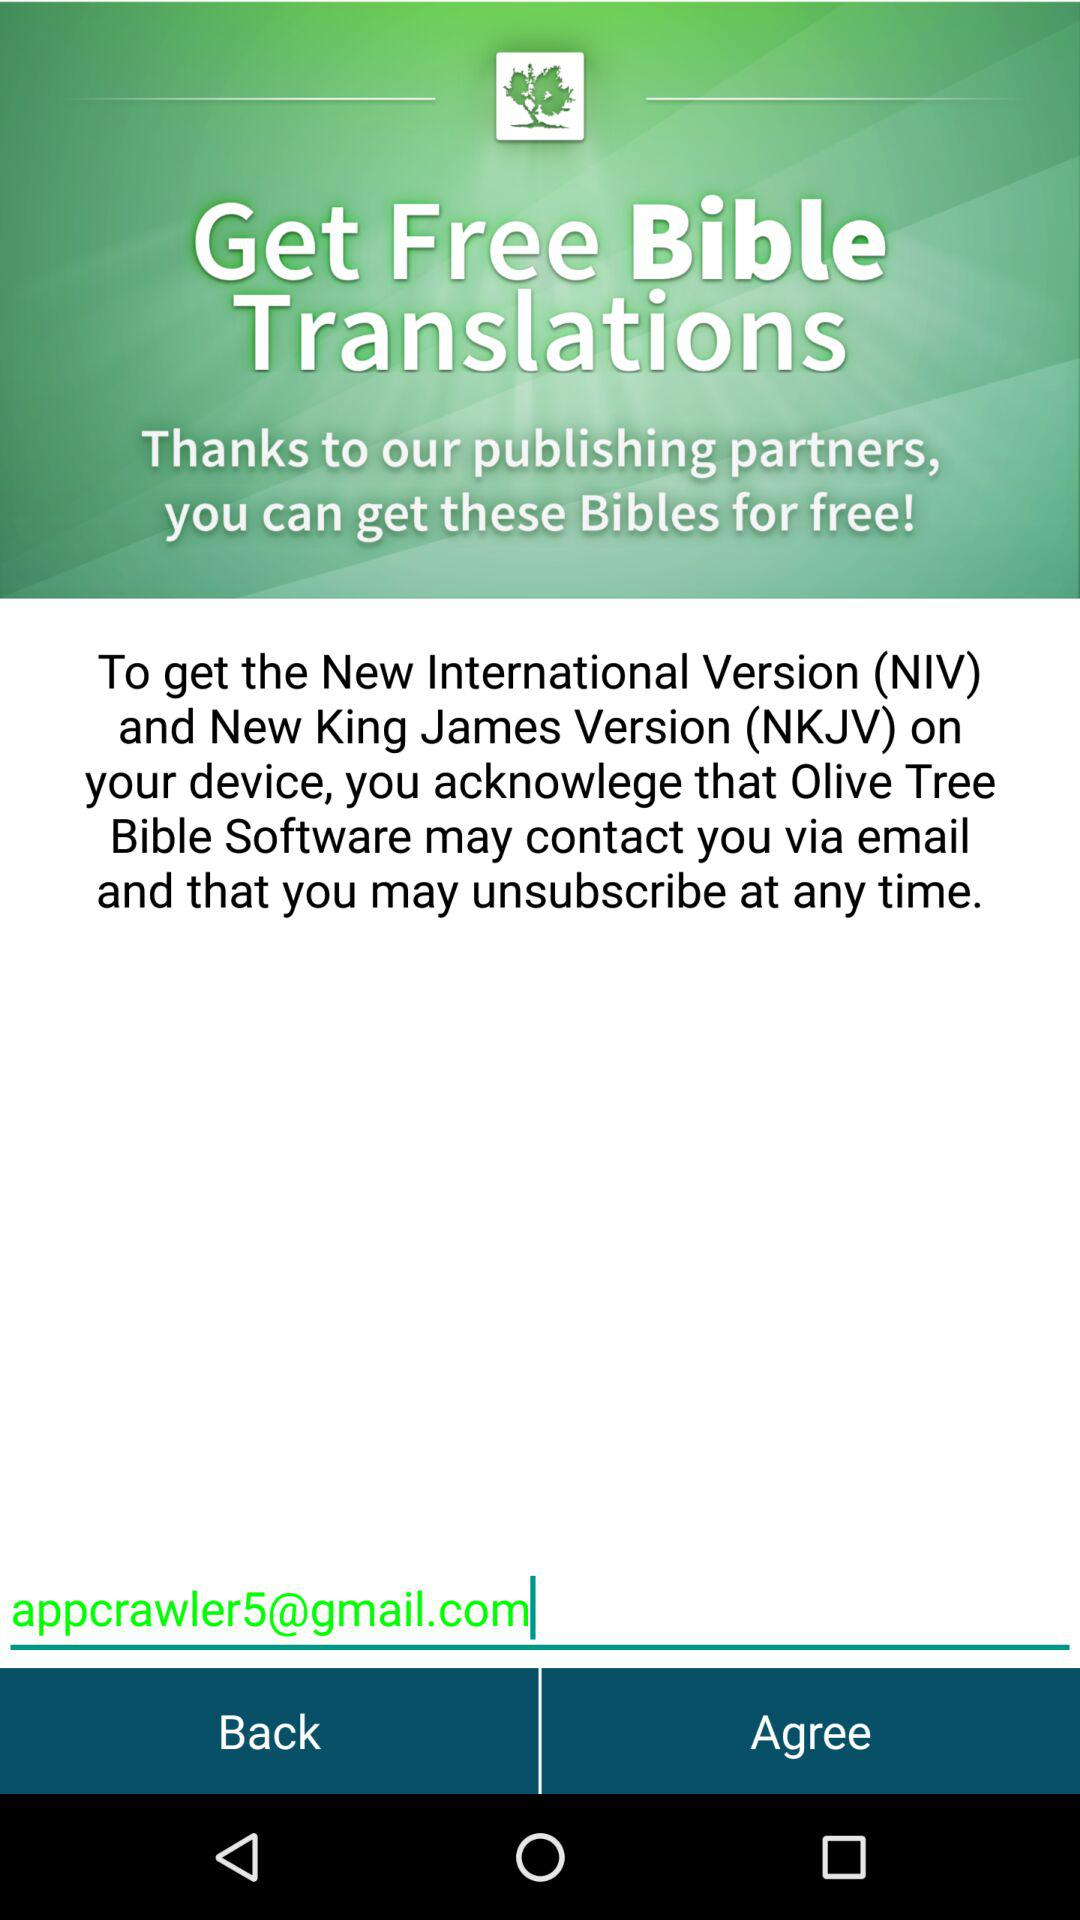What is the email address? The email address is appcrawler5@gmail.com. 